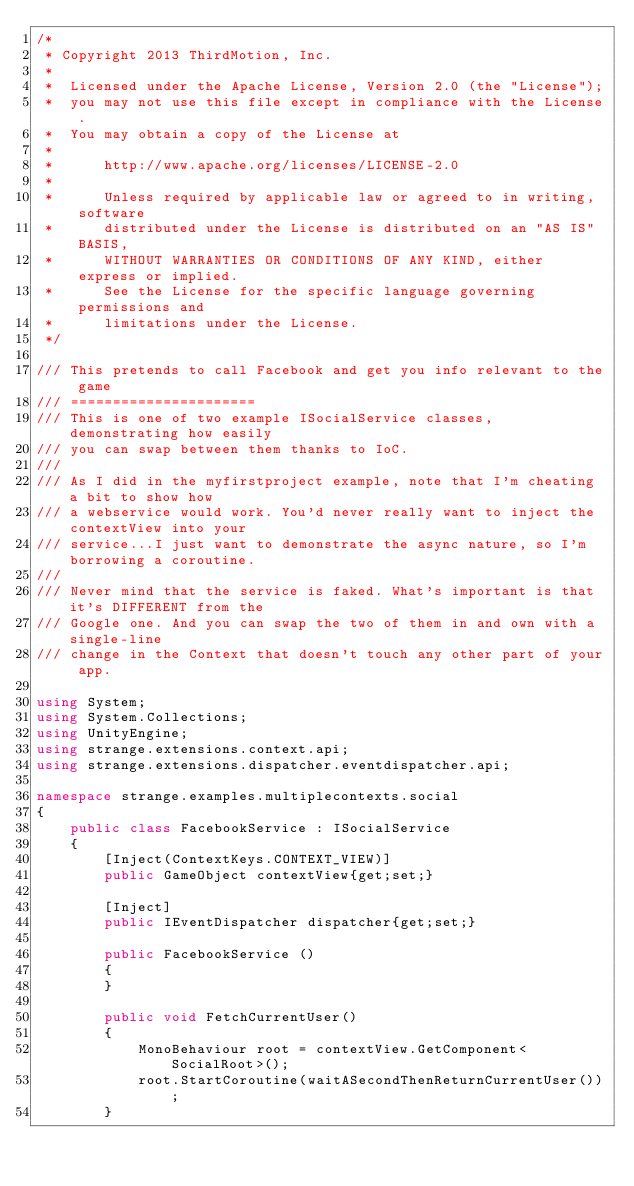Convert code to text. <code><loc_0><loc_0><loc_500><loc_500><_C#_>/*
 * Copyright 2013 ThirdMotion, Inc.
 *
 *	Licensed under the Apache License, Version 2.0 (the "License");
 *	you may not use this file except in compliance with the License.
 *	You may obtain a copy of the License at
 *
 *		http://www.apache.org/licenses/LICENSE-2.0
 *
 *		Unless required by applicable law or agreed to in writing, software
 *		distributed under the License is distributed on an "AS IS" BASIS,
 *		WITHOUT WARRANTIES OR CONDITIONS OF ANY KIND, either express or implied.
 *		See the License for the specific language governing permissions and
 *		limitations under the License.
 */

/// This pretends to call Facebook and get you info relevant to the game
/// ======================
/// This is one of two example ISocialService classes, demonstrating how easily
/// you can swap between them thanks to IoC.
/// 
/// As I did in the myfirstproject example, note that I'm cheating a bit to show how
/// a webservice would work. You'd never really want to inject the contextView into your
/// service...I just want to demonstrate the async nature, so I'm borrowing a coroutine.
/// 
/// Never mind that the service is faked. What's important is that it's DIFFERENT from the
/// Google one. And you can swap the two of them in and own with a single-line
/// change in the Context that doesn't touch any other part of your app.

using System;
using System.Collections;
using UnityEngine;
using strange.extensions.context.api;
using strange.extensions.dispatcher.eventdispatcher.api;

namespace strange.examples.multiplecontexts.social
{
	public class FacebookService : ISocialService
	{
		[Inject(ContextKeys.CONTEXT_VIEW)]
		public GameObject contextView{get;set;}
		
		[Inject]
		public IEventDispatcher dispatcher{get;set;}
		
		public FacebookService ()
		{
		}

		public void FetchCurrentUser()
		{
			MonoBehaviour root = contextView.GetComponent<SocialRoot>();
			root.StartCoroutine(waitASecondThenReturnCurrentUser());
		}
</code> 